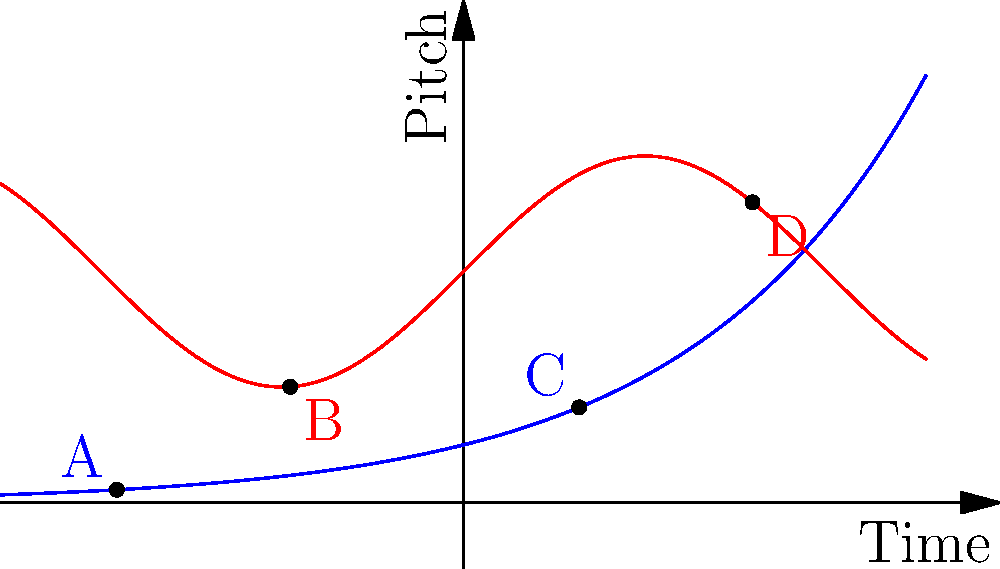In the graph above, which points represent the intersection of traditional Arab musical scales (blue curve) with modern compositional techniques (red curve) in contemporary Arab music? To answer this question, we need to analyze the graph step-by-step:

1. The blue curve represents traditional Arab musical scales, while the red curve represents modern compositional techniques.

2. Intersection points are where these two curves meet, indicating a fusion of traditional and modern elements.

3. Examining the graph, we can see that the blue and red curves intersect at two points:
   a. Near point A, around x = -3
   b. Between points C and D, around x = 2

4. These intersection points represent moments in the evolution of Arab music where traditional scales harmoniously blend with modern composition techniques.

5. Points B and D, while on the modern composition curve, do not represent intersections with the traditional scale.

Therefore, the intersection points, which represent the fusion of traditional Arab musical scales with modern compositional techniques, are found near point A and between points C and D.
Answer: Near A and between C and D 